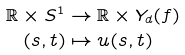Convert formula to latex. <formula><loc_0><loc_0><loc_500><loc_500>\mathbb { R } \times S ^ { 1 } & \to \mathbb { R } \times Y _ { d } ( f ) \\ ( s , t ) & \mapsto u ( s , t )</formula> 